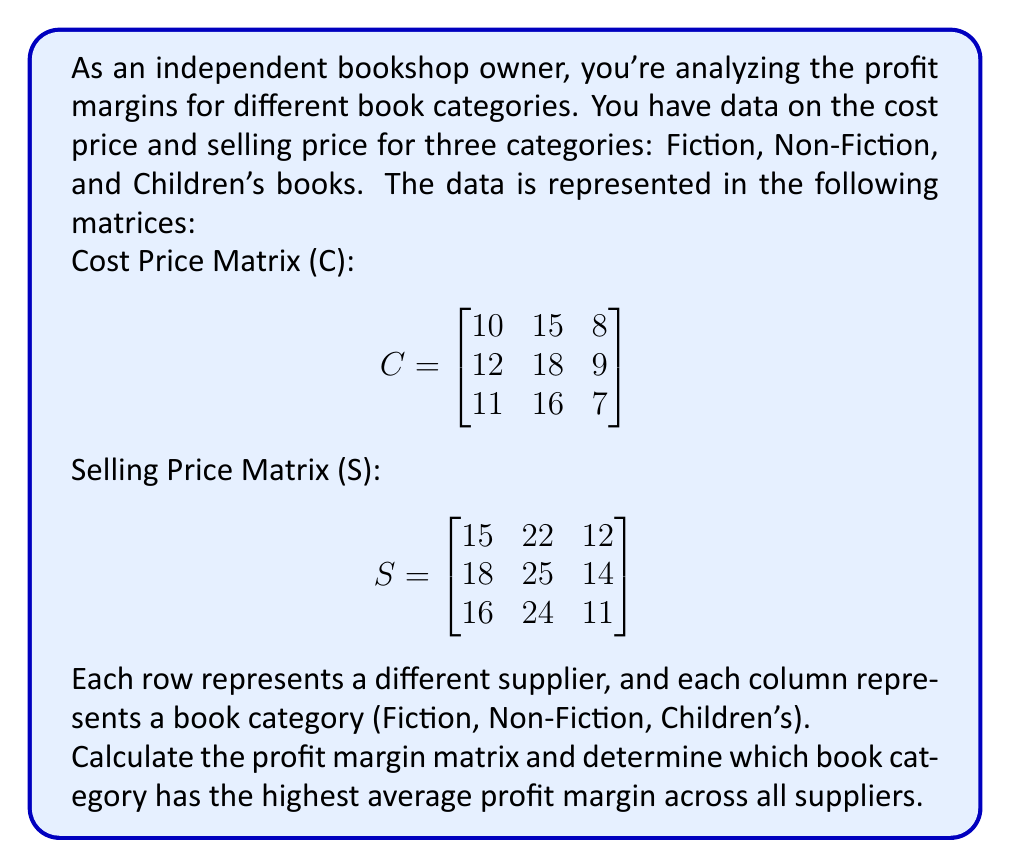What is the answer to this math problem? To solve this problem, we'll follow these steps:

1) Calculate the Profit Matrix (P):
   Profit = Selling Price - Cost Price
   $$P = S - C$$

2) Calculate the Profit Margin Matrix (M):
   Profit Margin = (Profit / Cost Price) * 100%
   $$M = (P \oslash C) * 100\%$$
   where $\oslash$ represents element-wise division.

3) Calculate the average profit margin for each category.

4) Determine the category with the highest average profit margin.

Step 1: Calculate the Profit Matrix (P)
$$P = S - C = \begin{bmatrix}
15-10 & 22-15 & 12-8 \\
18-12 & 25-18 & 14-9 \\
16-11 & 24-16 & 11-7
\end{bmatrix} = \begin{bmatrix}
5 & 7 & 4 \\
6 & 7 & 5 \\
5 & 8 & 4
\end{bmatrix}$$

Step 2: Calculate the Profit Margin Matrix (M)
$$M = (P \oslash C) * 100\% = \begin{bmatrix}
(5/10)*100\% & (7/15)*100\% & (4/8)*100\% \\
(6/12)*100\% & (7/18)*100\% & (5/9)*100\% \\
(5/11)*100\% & (8/16)*100\% & (4/7)*100\%
\end{bmatrix} = \begin{bmatrix}
50\% & 46.67\% & 50\% \\
50\% & 38.89\% & 55.56\% \\
45.45\% & 50\% & 57.14\%
\end{bmatrix}$$

Step 3: Calculate the average profit margin for each category
Fiction: $(50\% + 50\% + 45.45\%) / 3 = 48.48\%$
Non-Fiction: $(46.67\% + 38.89\% + 50\%) / 3 = 45.19\%$
Children's: $(50\% + 55.56\% + 57.14\%) / 3 = 54.23\%$

Step 4: Determine the category with the highest average profit margin
The Children's book category has the highest average profit margin at 54.23%.
Answer: The Children's book category has the highest average profit margin at 54.23%. 